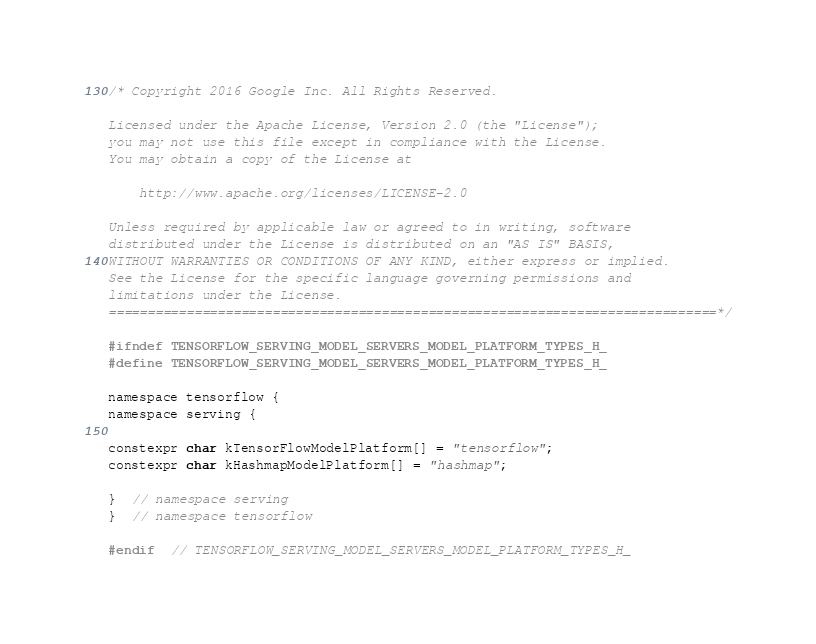Convert code to text. <code><loc_0><loc_0><loc_500><loc_500><_C_>/* Copyright 2016 Google Inc. All Rights Reserved.

Licensed under the Apache License, Version 2.0 (the "License");
you may not use this file except in compliance with the License.
You may obtain a copy of the License at

    http://www.apache.org/licenses/LICENSE-2.0

Unless required by applicable law or agreed to in writing, software
distributed under the License is distributed on an "AS IS" BASIS,
WITHOUT WARRANTIES OR CONDITIONS OF ANY KIND, either express or implied.
See the License for the specific language governing permissions and
limitations under the License.
==============================================================================*/

#ifndef TENSORFLOW_SERVING_MODEL_SERVERS_MODEL_PLATFORM_TYPES_H_
#define TENSORFLOW_SERVING_MODEL_SERVERS_MODEL_PLATFORM_TYPES_H_

namespace tensorflow {
namespace serving {

constexpr char kTensorFlowModelPlatform[] = "tensorflow";
constexpr char kHashmapModelPlatform[] = "hashmap";

}  // namespace serving
}  // namespace tensorflow

#endif  // TENSORFLOW_SERVING_MODEL_SERVERS_MODEL_PLATFORM_TYPES_H_
</code> 